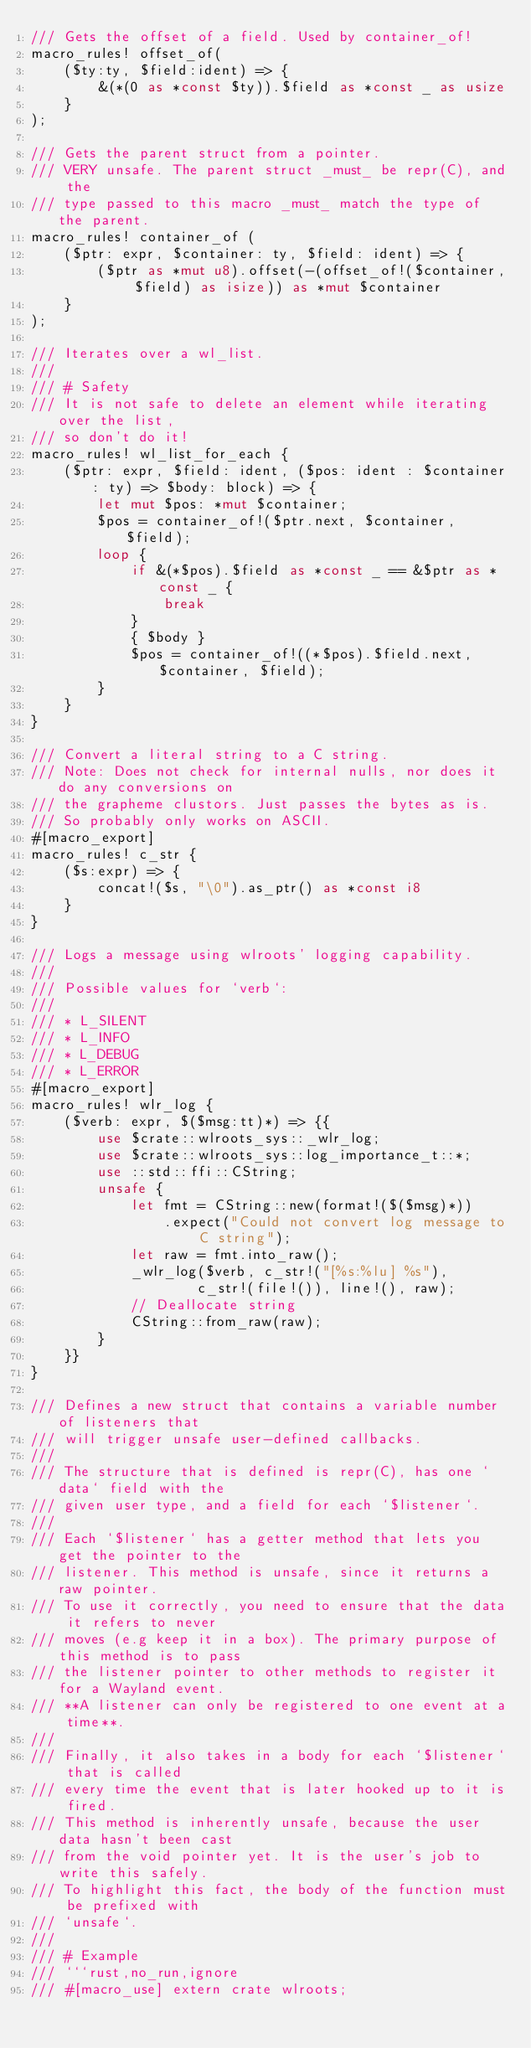<code> <loc_0><loc_0><loc_500><loc_500><_Rust_>/// Gets the offset of a field. Used by container_of!
macro_rules! offset_of(
    ($ty:ty, $field:ident) => {
        &(*(0 as *const $ty)).$field as *const _ as usize
    }
);

/// Gets the parent struct from a pointer.
/// VERY unsafe. The parent struct _must_ be repr(C), and the
/// type passed to this macro _must_ match the type of the parent.
macro_rules! container_of (
    ($ptr: expr, $container: ty, $field: ident) => {
        ($ptr as *mut u8).offset(-(offset_of!($container, $field) as isize)) as *mut $container
    }
);

/// Iterates over a wl_list.
///
/// # Safety
/// It is not safe to delete an element while iterating over the list,
/// so don't do it!
macro_rules! wl_list_for_each {
    ($ptr: expr, $field: ident, ($pos: ident : $container: ty) => $body: block) => {
        let mut $pos: *mut $container;
        $pos = container_of!($ptr.next, $container, $field);
        loop {
            if &(*$pos).$field as *const _ == &$ptr as *const _ {
                break
            }
            { $body }
            $pos = container_of!((*$pos).$field.next, $container, $field);
        }
    }
}

/// Convert a literal string to a C string.
/// Note: Does not check for internal nulls, nor does it do any conversions on
/// the grapheme clustors. Just passes the bytes as is.
/// So probably only works on ASCII.
#[macro_export]
macro_rules! c_str {
    ($s:expr) => {
        concat!($s, "\0").as_ptr() as *const i8
    }
}

/// Logs a message using wlroots' logging capability.
///
/// Possible values for `verb`:
///
/// * L_SILENT
/// * L_INFO
/// * L_DEBUG
/// * L_ERROR
#[macro_export]
macro_rules! wlr_log {
    ($verb: expr, $($msg:tt)*) => {{
        use $crate::wlroots_sys::_wlr_log;
        use $crate::wlroots_sys::log_importance_t::*;
        use ::std::ffi::CString;
        unsafe {
            let fmt = CString::new(format!($($msg)*))
                .expect("Could not convert log message to C string");
            let raw = fmt.into_raw();
            _wlr_log($verb, c_str!("[%s:%lu] %s"),
                    c_str!(file!()), line!(), raw);
            // Deallocate string
            CString::from_raw(raw);
        }
    }}
}

/// Defines a new struct that contains a variable number of listeners that
/// will trigger unsafe user-defined callbacks.
///
/// The structure that is defined is repr(C), has one `data` field with the
/// given user type, and a field for each `$listener`.
///
/// Each `$listener` has a getter method that lets you get the pointer to the
/// listener. This method is unsafe, since it returns a raw pointer.
/// To use it correctly, you need to ensure that the data it refers to never
/// moves (e.g keep it in a box). The primary purpose of this method is to pass
/// the listener pointer to other methods to register it for a Wayland event.
/// **A listener can only be registered to one event at a time**.
///
/// Finally, it also takes in a body for each `$listener` that is called
/// every time the event that is later hooked up to it is fired.
/// This method is inherently unsafe, because the user data hasn't been cast
/// from the void pointer yet. It is the user's job to write this safely.
/// To highlight this fact, the body of the function must be prefixed with
/// `unsafe`.
///
/// # Example
/// ```rust,no_run,ignore
/// #[macro_use] extern crate wlroots;</code> 